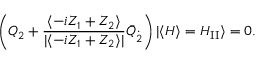<formula> <loc_0><loc_0><loc_500><loc_500>\left ( Q _ { 2 } + \frac { \langle - i Z _ { 1 } + Z _ { 2 } \rangle } { | \langle - i Z _ { 1 } + Z _ { 2 } \rangle | } \bar { Q } _ { \dot { 2 } } \right ) | \langle H \rangle = H _ { I I } \rangle = 0 .</formula> 